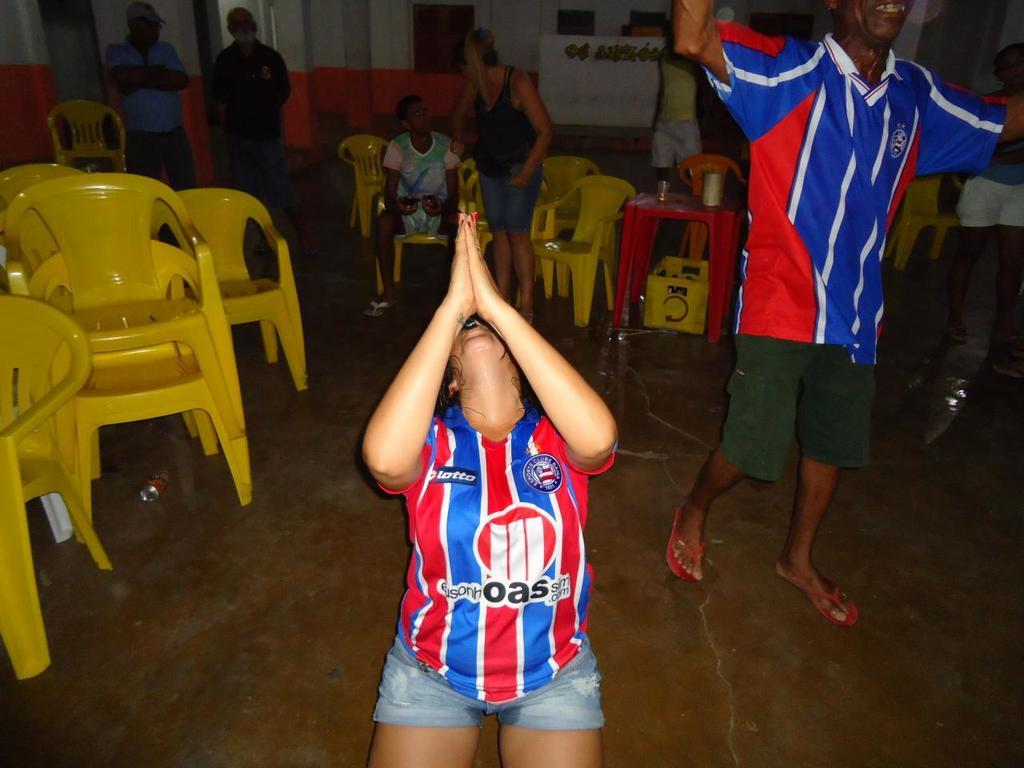<image>
Provide a brief description of the given image. The lady sitting on the ground praying was the letters OAS in the centre of her top. 